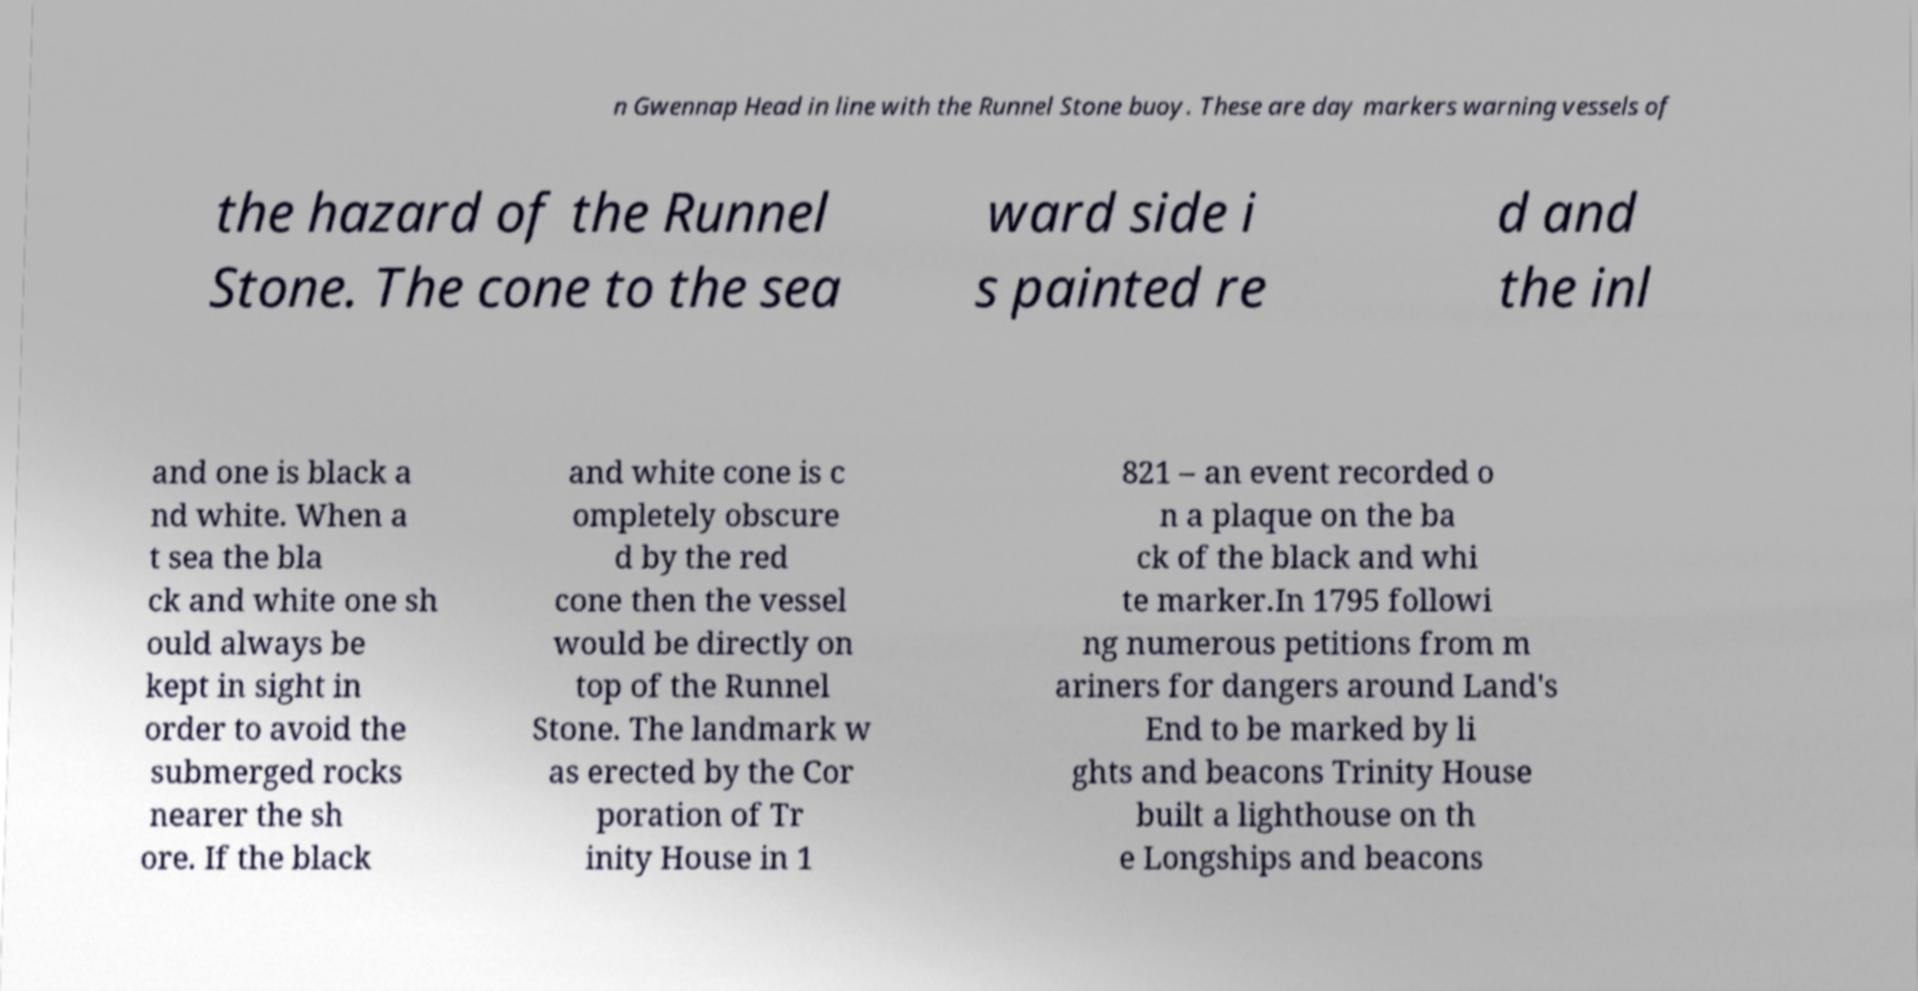I need the written content from this picture converted into text. Can you do that? n Gwennap Head in line with the Runnel Stone buoy. These are day markers warning vessels of the hazard of the Runnel Stone. The cone to the sea ward side i s painted re d and the inl and one is black a nd white. When a t sea the bla ck and white one sh ould always be kept in sight in order to avoid the submerged rocks nearer the sh ore. If the black and white cone is c ompletely obscure d by the red cone then the vessel would be directly on top of the Runnel Stone. The landmark w as erected by the Cor poration of Tr inity House in 1 821 – an event recorded o n a plaque on the ba ck of the black and whi te marker.In 1795 followi ng numerous petitions from m ariners for dangers around Land's End to be marked by li ghts and beacons Trinity House built a lighthouse on th e Longships and beacons 